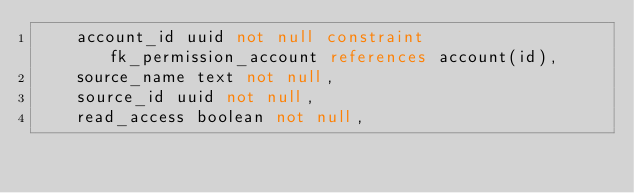Convert code to text. <code><loc_0><loc_0><loc_500><loc_500><_SQL_>    account_id uuid not null constraint fk_permission_account references account(id),
    source_name text not null,
    source_id uuid not null,
    read_access boolean not null,</code> 